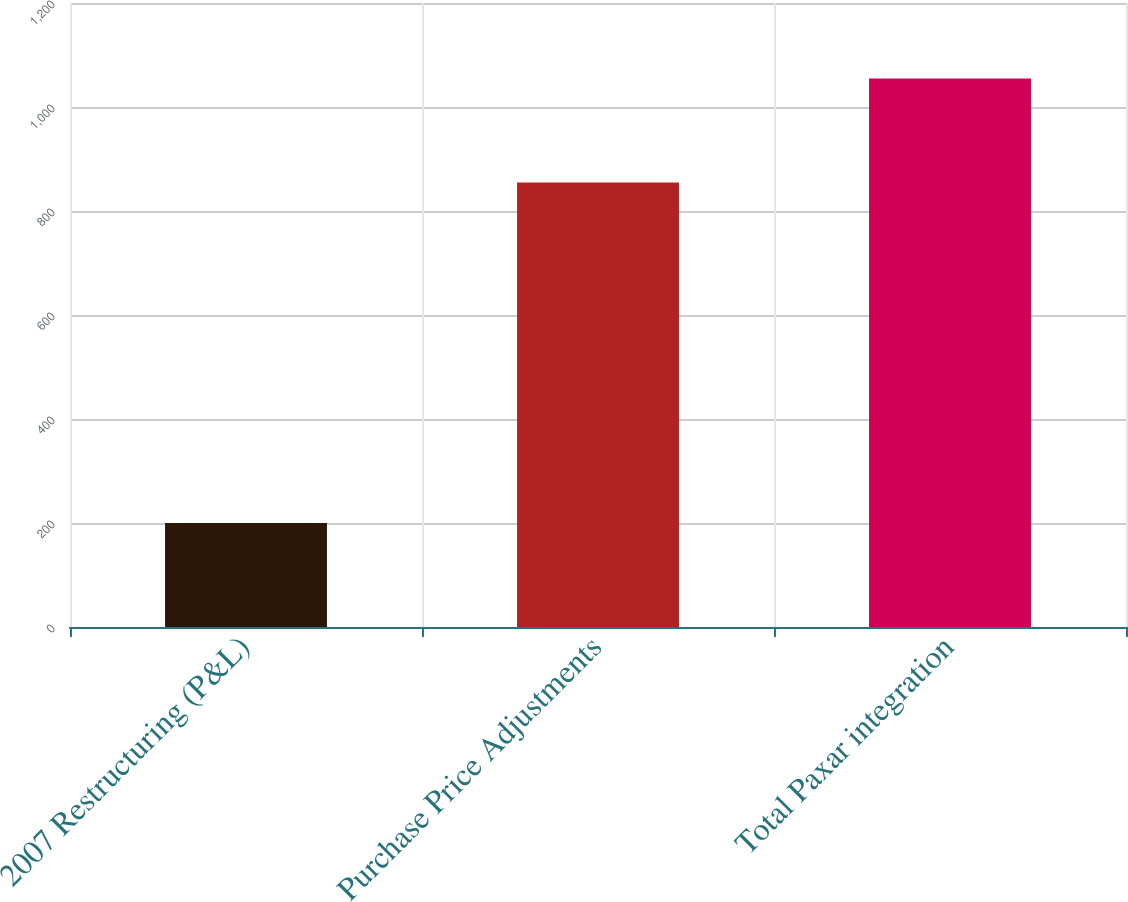<chart> <loc_0><loc_0><loc_500><loc_500><bar_chart><fcel>2007 Restructuring (P&L)<fcel>Purchase Price Adjustments<fcel>Total Paxar integration<nl><fcel>200<fcel>855<fcel>1055<nl></chart> 